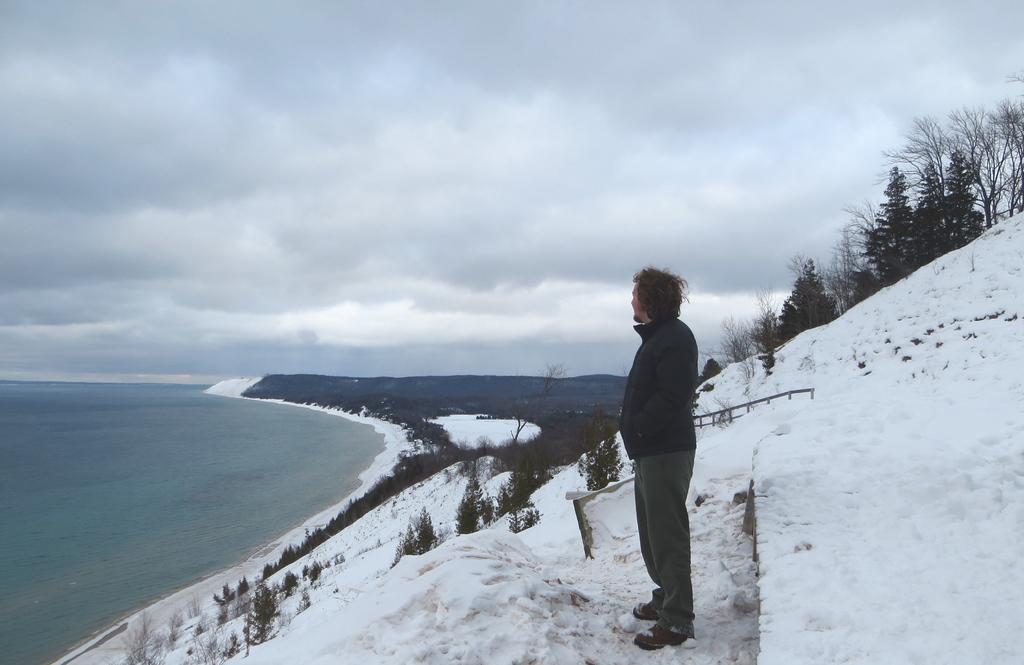Please provide a concise description of this image. In the image we can see there is a person standing on the ground and the ground is covered with snow. Behind there are trees and there is a sea shore at the bottom. 